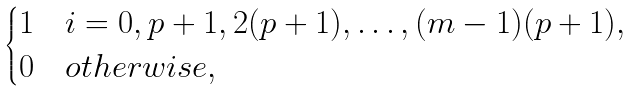<formula> <loc_0><loc_0><loc_500><loc_500>\begin{cases} 1 \quad i = 0 , p + 1 , 2 ( p + 1 ) , \dots , ( m - 1 ) ( p + 1 ) , \\ 0 \quad o t h e r w i s e , \end{cases}</formula> 